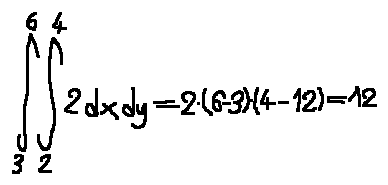<formula> <loc_0><loc_0><loc_500><loc_500>\int \lim i t s _ { 3 } ^ { 6 } \int \lim i t s _ { 2 } ^ { 4 } 2 d x d y = 2 \cdot ( 6 - 3 ) \cdot ( 4 - 1 2 ) = 1 2</formula> 